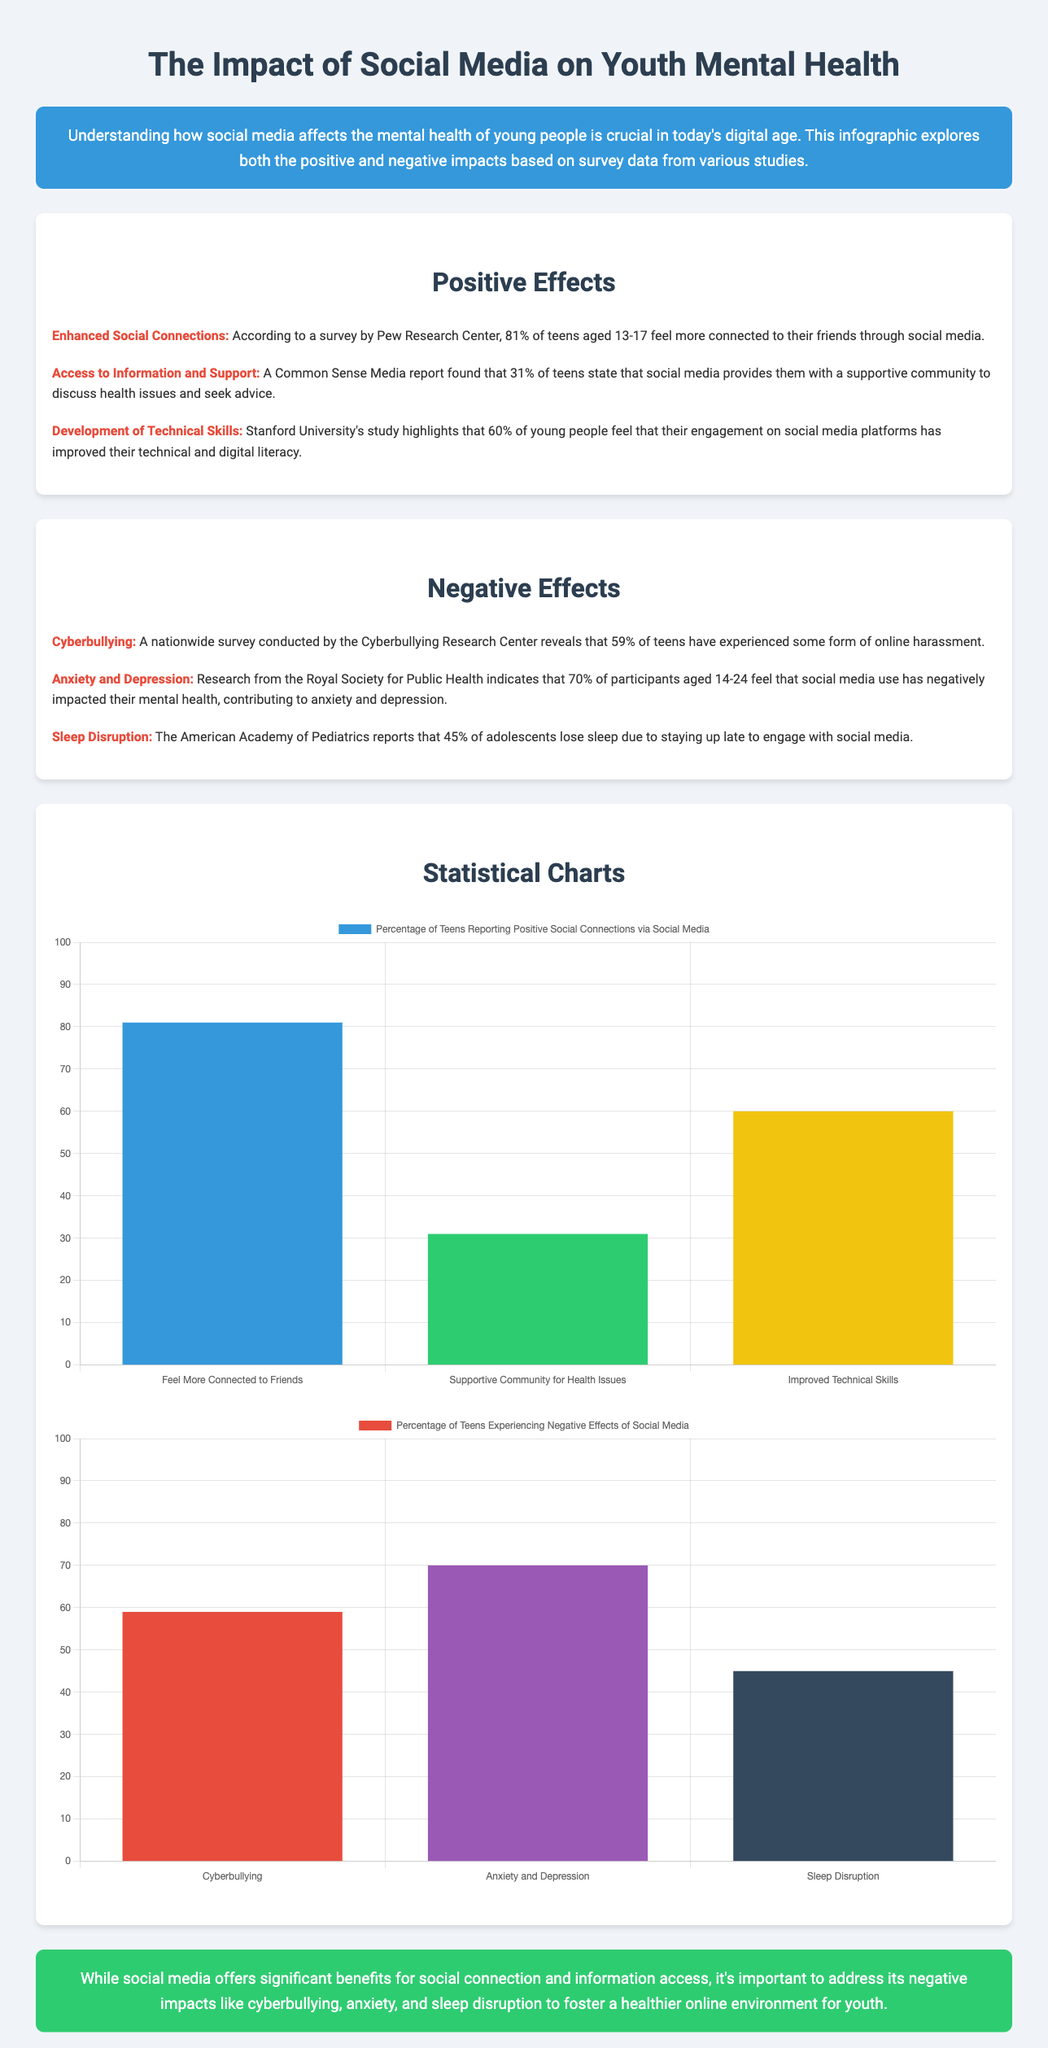What percentage of teens feel more connected to friends through social media? The document states that 81% of teens aged 13-17 feel more connected to their friends through social media, according to a survey by Pew Research Center.
Answer: 81% What organization reported that 31% of teens find a supportive community for health issues on social media? The supportive community statistic is found in a report by Common Sense Media, indicating that 31% of teens state social media provides such community.
Answer: Common Sense Media What is the percentage of teens who have experienced cyberbullying? A nationwide survey conducted by the Cyberbullying Research Center reveals that 59% of teens have experienced some form of online harassment.
Answer: 59% Which negative mental health effect affects 70% of participants aged 14-24 according to the Royal Society for Public Health? The document indicates that 70% of participants feel that social media use has negatively impacted their mental health, contributing to anxiety and depression.
Answer: Anxiety and depression What is the main conclusion of the infographic? The conclusion emphasizes that while social media offers significant benefits for social connection and information access, it is important to address its negative impacts to foster a healthier online environment for youth.
Answer: Address negative impacts What positive effect of social media has been reported as improving digital literacy in 60% of young people? According to Stanford University’s study, 60% of young people feel that engagement on social media platforms has improved their technical and digital literacy.
Answer: Improved technical skills What is the maximum percentage shown on the y-axis for the charts in the infographic? The charts in the document have a maximum y-axis value of 100, indicating the percentage of teens affected by the variables presented.
Answer: 100 How many percentages are shown for each positive effect in the chart? The visual data includes three percentages corresponding to the effects of enhanced social connections, access to information, and improved technical skills, providing a comparative view.
Answer: Three 